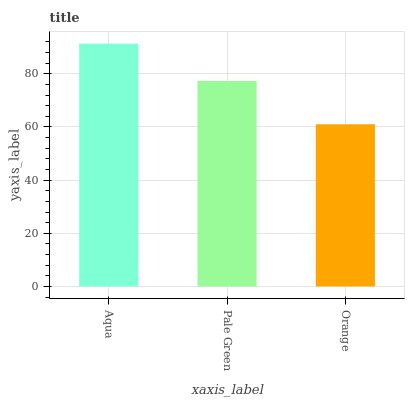Is Pale Green the minimum?
Answer yes or no. No. Is Pale Green the maximum?
Answer yes or no. No. Is Aqua greater than Pale Green?
Answer yes or no. Yes. Is Pale Green less than Aqua?
Answer yes or no. Yes. Is Pale Green greater than Aqua?
Answer yes or no. No. Is Aqua less than Pale Green?
Answer yes or no. No. Is Pale Green the high median?
Answer yes or no. Yes. Is Pale Green the low median?
Answer yes or no. Yes. Is Orange the high median?
Answer yes or no. No. Is Aqua the low median?
Answer yes or no. No. 